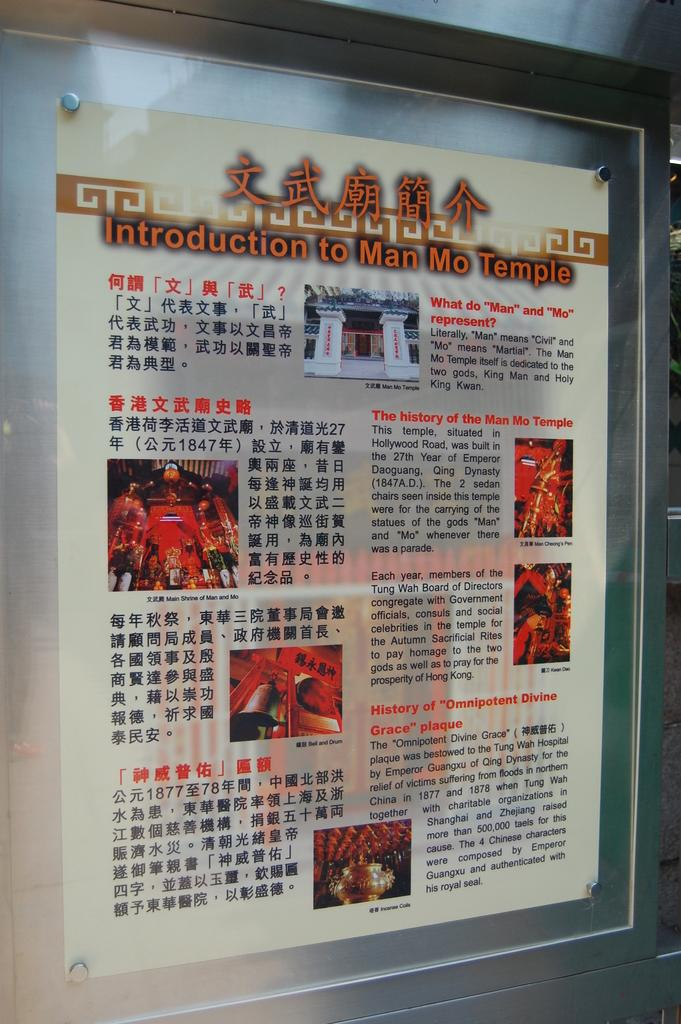<image>
Provide a brief description of the given image. A poster that is in Asian writing for the Introduction to Man Mo Temple. 